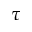Convert formula to latex. <formula><loc_0><loc_0><loc_500><loc_500>\tau</formula> 